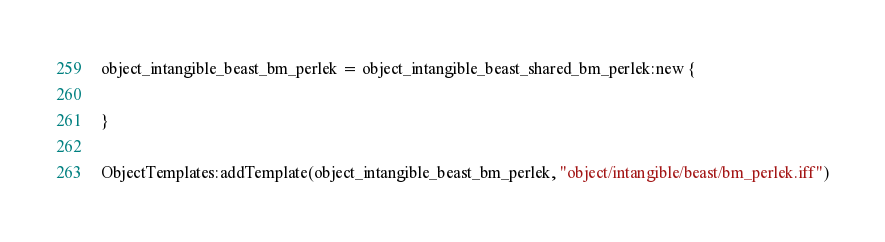<code> <loc_0><loc_0><loc_500><loc_500><_Lua_>object_intangible_beast_bm_perlek = object_intangible_beast_shared_bm_perlek:new {

}

ObjectTemplates:addTemplate(object_intangible_beast_bm_perlek, "object/intangible/beast/bm_perlek.iff")
</code> 